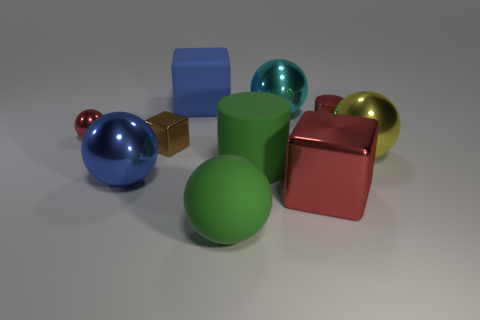Is the number of blue rubber blocks that are right of the rubber sphere less than the number of brown rubber cylinders?
Your answer should be compact. No. What number of small gray cubes are there?
Your answer should be very brief. 0. How many shiny objects have the same color as the big shiny cube?
Offer a terse response. 2. Do the big cyan shiny thing and the tiny brown metallic thing have the same shape?
Offer a very short reply. No. What is the size of the red metal object that is in front of the sphere that is right of the large cyan metal thing?
Provide a succinct answer. Large. Are there any red cylinders that have the same size as the brown metallic thing?
Offer a terse response. Yes. Is the size of the metallic cylinder that is in front of the blue matte block the same as the metal sphere to the right of the red shiny cube?
Ensure brevity in your answer.  No. What shape is the red metal thing that is in front of the large green object on the right side of the big green sphere?
Ensure brevity in your answer.  Cube. What number of large balls are behind the large cyan shiny thing?
Give a very brief answer. 0. There is a tiny ball that is made of the same material as the big cyan thing; what color is it?
Your answer should be very brief. Red. 